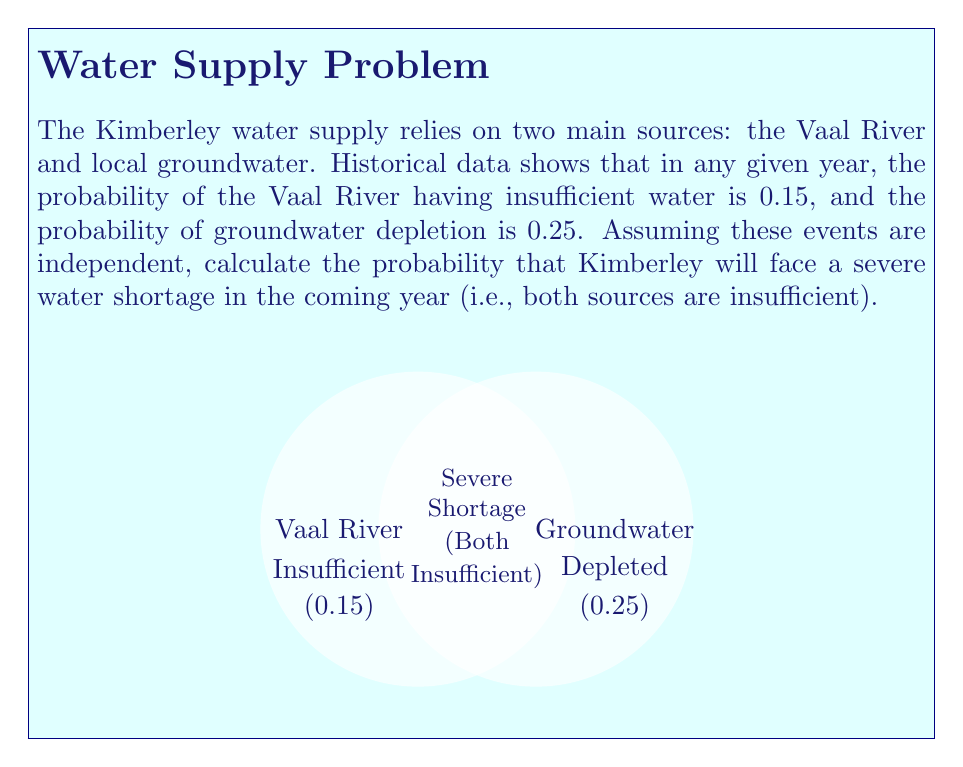Could you help me with this problem? To solve this problem, we'll use the multiplication rule for independent events. The steps are as follows:

1) Let's define our events:
   A: Vaal River has insufficient water
   B: Groundwater is depleted

2) We're given:
   P(A) = 0.15
   P(B) = 0.25

3) We need to find P(A and B), which represents the probability of a severe water shortage.

4) Since the events are independent, we can use the multiplication rule:

   $$P(A \text{ and } B) = P(A) \times P(B)$$

5) Substituting the values:

   $$P(A \text{ and } B) = 0.15 \times 0.25$$

6) Calculating:

   $$P(A \text{ and } B) = 0.0375$$

7) Converting to a percentage:

   $$0.0375 \times 100\% = 3.75\%$$

Therefore, the probability that Kimberley will face a severe water shortage in the coming year is 0.0375 or 3.75%.
Answer: 0.0375 or 3.75% 